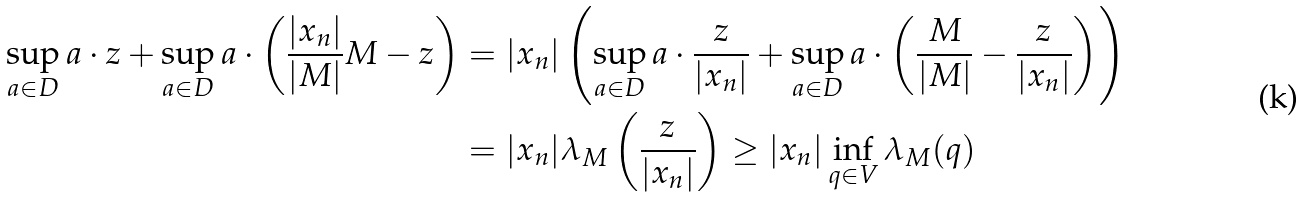Convert formula to latex. <formula><loc_0><loc_0><loc_500><loc_500>\sup _ { a \in D } a \cdot z + \sup _ { a \in D } a \cdot \left ( \frac { | x _ { n } | } { | M | } M - z \right ) & = | x _ { n } | \left ( \sup _ { a \in D } a \cdot \frac { z } { | x _ { n } | } + \sup _ { a \in D } a \cdot \left ( \frac { M } { | M | } - \frac { z } { | x _ { n } | } \right ) \right ) \\ & = | x _ { n } | \lambda _ { M } \left ( \frac { z } { | x _ { n } | } \right ) \geq | x _ { n } | \inf _ { q \in V } \lambda _ { M } ( q )</formula> 